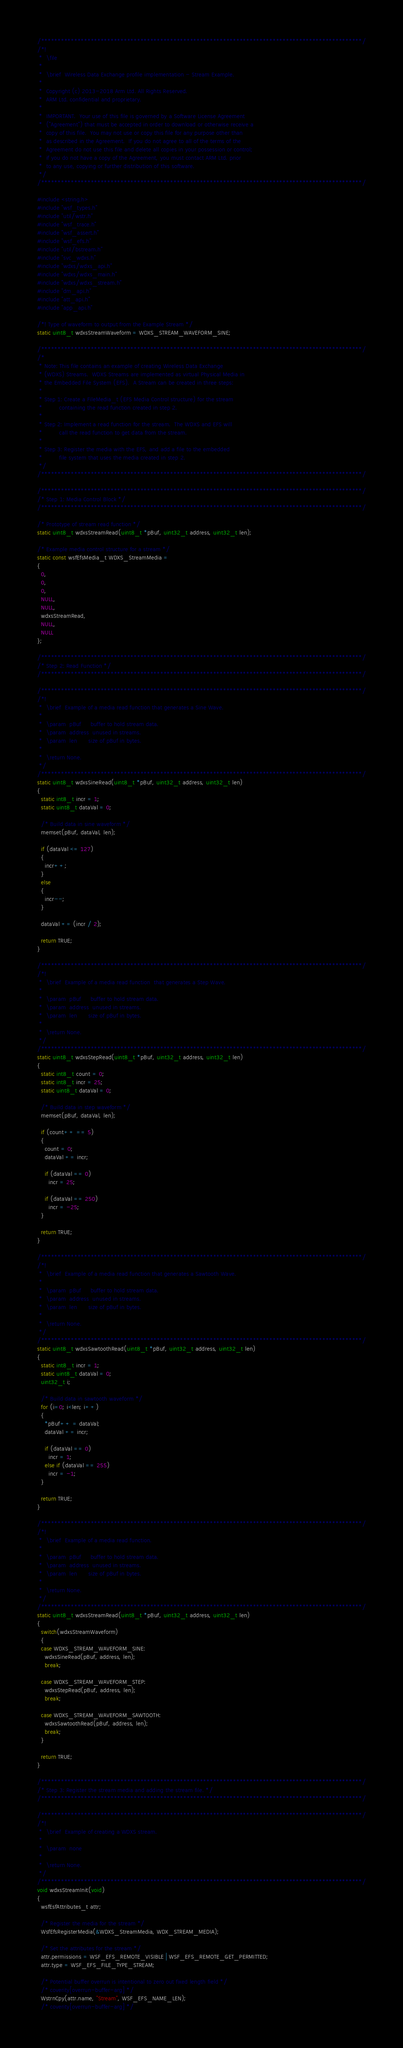Convert code to text. <code><loc_0><loc_0><loc_500><loc_500><_C_>/*************************************************************************************************/
/*!
 *  \file
 *
 *  \brief  Wireless Data Exchange profile implementation - Stream Example.
 *
 *  Copyright (c) 2013-2018 Arm Ltd. All Rights Reserved.
 *  ARM Ltd. confidential and proprietary.
 *
 *  IMPORTANT.  Your use of this file is governed by a Software License Agreement
 *  ("Agreement") that must be accepted in order to download or otherwise receive a
 *  copy of this file.  You may not use or copy this file for any purpose other than
 *  as described in the Agreement.  If you do not agree to all of the terms of the
 *  Agreement do not use this file and delete all copies in your possession or control;
 *  if you do not have a copy of the Agreement, you must contact ARM Ltd. prior
 *  to any use, copying or further distribution of this software.
 */
/*************************************************************************************************/

#include <string.h>
#include "wsf_types.h"
#include "util/wstr.h"
#include "wsf_trace.h"
#include "wsf_assert.h"
#include "wsf_efs.h"
#include "util/bstream.h"
#include "svc_wdxs.h"
#include "wdxs/wdxs_api.h"
#include "wdxs/wdxs_main.h"
#include "wdxs/wdxs_stream.h"
#include "dm_api.h"
#include "att_api.h"
#include "app_api.h"

/*! Type of waveform to output from the Example Stream */
static uint8_t wdxsStreamWaveform = WDXS_STREAM_WAVEFORM_SINE;

/*************************************************************************************************/
/*
 * Note: This file contains an example of creating Wireless Data Exchange
 * (WDXS) Streams.  WDXS Streams are implemented as virtual Physical Media in
 * the Embedded File System (EFS).  A Stream can be created in three steps:
 *
 * Step 1: Create a FileMedia_t (EFS Media Control structure) for the stream
 *         containing the read function created in step 2.
 *
 * Step 2: Implement a read function for the stream.  The WDXS and EFS will
 *         call the read function to get data from the stream.
 *
 * Step 3: Register the media with the EFS, and add a file to the embedded
 *         file system that uses the media created in step 2.
 */
/*************************************************************************************************/

/*************************************************************************************************/
/* Step 1: Media Control Block */
/*************************************************************************************************/

/* Prototype of stream read function */
static uint8_t wdxsStreamRead(uint8_t *pBuf, uint32_t address, uint32_t len);

/* Example media control structure for a stream */
static const wsfEfsMedia_t WDXS_StreamMedia =
{
  0,
  0,
  0,
  NULL,
  NULL,
  wdxsStreamRead,
  NULL,
  NULL
};

/*************************************************************************************************/
/* Step 2: Read Function */
/*************************************************************************************************/

/*************************************************************************************************/
/*!
 *  \brief  Example of a media read function that generates a Sine Wave.
 *
 *  \param  pBuf     buffer to hold stream data.
 *  \param  address  unused in streams.
 *  \param  len      size of pBuf in bytes.
 *
 *  \return None.
 */
/*************************************************************************************************/
static uint8_t wdxsSineRead(uint8_t *pBuf, uint32_t address, uint32_t len)
{
  static int8_t incr = 1;
  static uint8_t dataVal = 0;

  /* Build data in sine waveform */
  memset(pBuf, dataVal, len);

  if (dataVal <= 127)
  {
    incr++;
  }
  else
  {
    incr--;
  }

  dataVal += (incr / 2);

  return TRUE;
}

/*************************************************************************************************/
/*!
 *  \brief  Example of a media read function  that generates a Step Wave.
 *
 *  \param  pBuf     buffer to hold stream data.
 *  \param  address  unused in streams.
 *  \param  len      size of pBuf in bytes.
 *
 *  \return None.
 */
/*************************************************************************************************/
static uint8_t wdxsStepRead(uint8_t *pBuf, uint32_t address, uint32_t len)
{
  static int8_t count = 0;
  static int8_t incr = 25;
  static uint8_t dataVal = 0;

  /* Build data in step waveform */
  memset(pBuf, dataVal, len);

  if (count++ == 5)
  {
    count = 0;
    dataVal += incr;

    if (dataVal == 0)
      incr = 25;

    if (dataVal == 250)
      incr = -25;
  }

  return TRUE;
}

/*************************************************************************************************/
/*!
 *  \brief  Example of a media read function that generates a Sawtooth Wave.
 *
 *  \param  pBuf     buffer to hold stream data.
 *  \param  address  unused in streams.
 *  \param  len      size of pBuf in bytes.
 *
 *  \return None.
 */
/*************************************************************************************************/
static uint8_t wdxsSawtoothRead(uint8_t *pBuf, uint32_t address, uint32_t len)
{
  static int8_t incr = 1;
  static uint8_t dataVal = 0;
  uint32_t i;

  /* Build data in sawtooth waveform */
  for (i=0; i<len; i++)
  {
    *pBuf++ = dataVal;
    dataVal += incr;

    if (dataVal == 0)
      incr = 1;
    else if (dataVal == 255)
      incr = -1;
  }

  return TRUE;
}

/*************************************************************************************************/
/*!
 *  \brief  Example of a media read function.
 *
 *  \param  pBuf     buffer to hold stream data.
 *  \param  address  unused in streams.
 *  \param  len      size of pBuf in bytes.
 *
 *  \return None.
 */
/*************************************************************************************************/
static uint8_t wdxsStreamRead(uint8_t *pBuf, uint32_t address, uint32_t len)
{
  switch(wdxsStreamWaveform)
  {
  case WDXS_STREAM_WAVEFORM_SINE:
    wdxsSineRead(pBuf, address, len);
    break;

  case WDXS_STREAM_WAVEFORM_STEP:
    wdxsStepRead(pBuf, address, len);
    break;

  case WDXS_STREAM_WAVEFORM_SAWTOOTH:
    wdxsSawtoothRead(pBuf, address, len);
    break;
  }

  return TRUE;
}

/*************************************************************************************************/
/* Step 3: Register the stream media and adding the stream file. */
/*************************************************************************************************/

/*************************************************************************************************/
/*!
 *  \brief  Example of creating a WDXS stream.
 *
 *  \param  none
 *
 *  \return None.
 */
/*************************************************************************************************/
void wdxsStreamInit(void)
{
  wsfEsfAttributes_t attr;

  /* Register the media for the stream */
  WsfEfsRegisterMedia(&WDXS_StreamMedia, WDX_STREAM_MEDIA);

  /* Set the attributes for the stream */
  attr.permissions = WSF_EFS_REMOTE_VISIBLE | WSF_EFS_REMOTE_GET_PERMITTED;
  attr.type = WSF_EFS_FILE_TYPE_STREAM;

  /* Potential buffer overrun is intentional to zero out fixed length field */
  /* coverity[overrun-buffer-arg] */
  WstrnCpy(attr.name, "Stream", WSF_EFS_NAME_LEN);
  /* coverity[overrun-buffer-arg] */</code> 